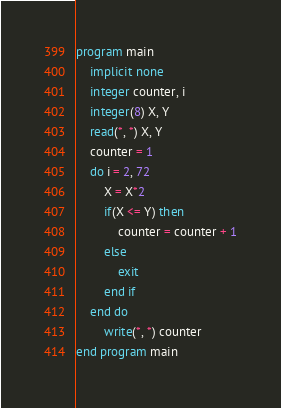<code> <loc_0><loc_0><loc_500><loc_500><_FORTRAN_>program main
	implicit none
	integer counter, i
	integer(8) X, Y
	read(*, *) X, Y
	counter = 1
	do i = 2, 72
		X = X*2
		if(X <= Y) then
			counter = counter + 1
		else
			exit
		end if
	end do
		write(*, *) counter
end program main</code> 